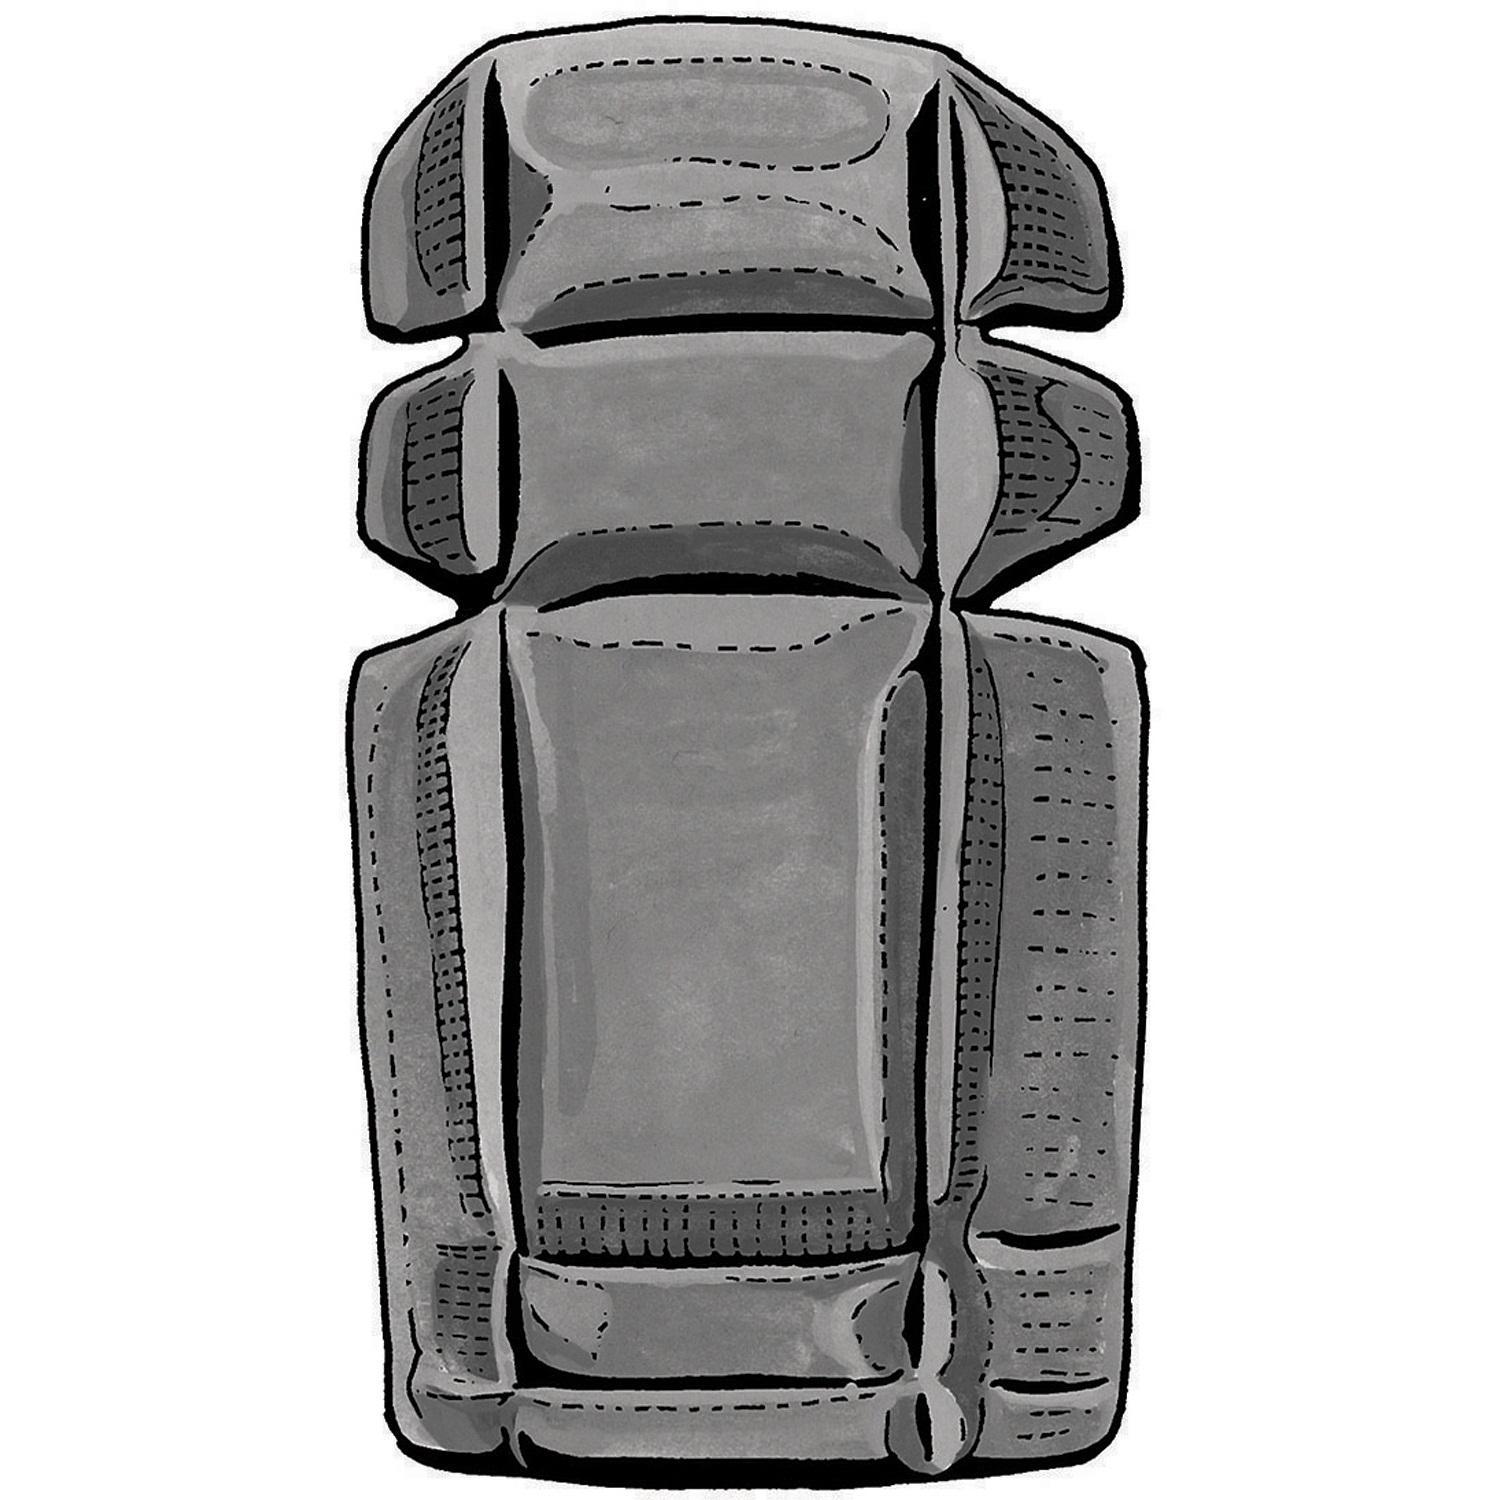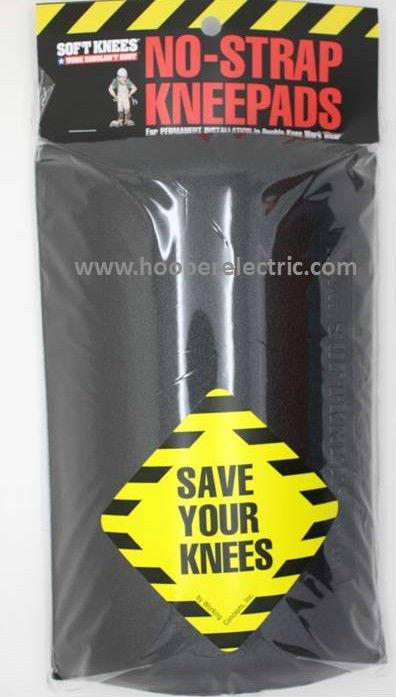The first image is the image on the left, the second image is the image on the right. Analyze the images presented: Is the assertion "An image shows a notched kneepad, with slits at the sides." valid? Answer yes or no. Yes. The first image is the image on the left, the second image is the image on the right. Examine the images to the left and right. Is the description "At least one of the knee pads is textured." accurate? Answer yes or no. Yes. 